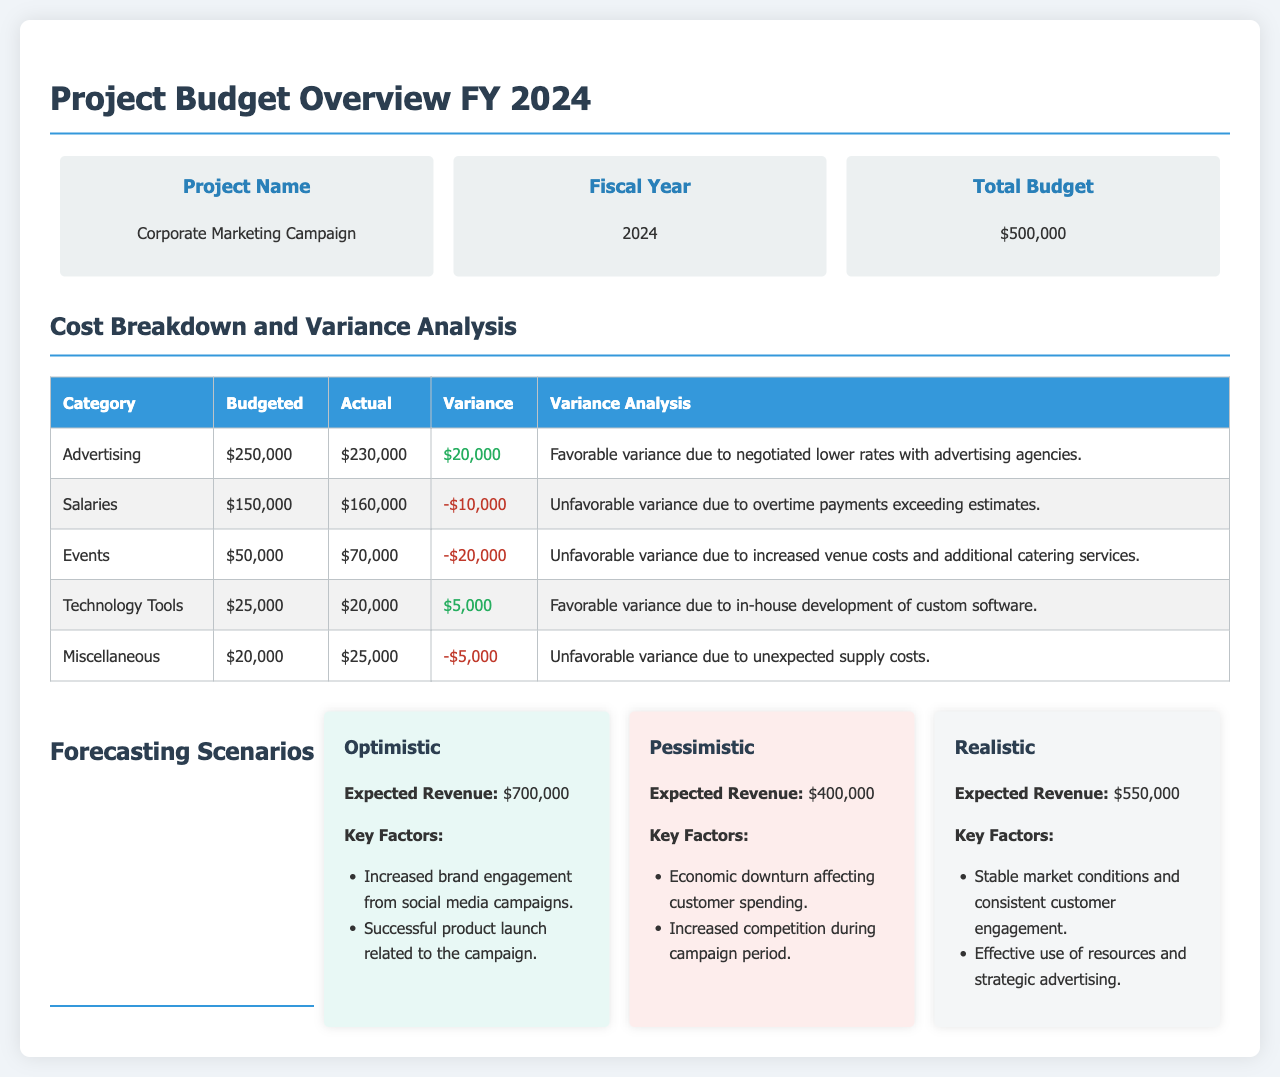What is the project name? The project name is listed in the budget overview section of the document.
Answer: Corporate Marketing Campaign What is the total budget? The total budget is stated in the budget overview section.
Answer: $500,000 What was the actual spending on Advertising? The actual spending on Advertising is provided in the cost breakdown table.
Answer: $230,000 What is the variance for Salaries? The variance for Salaries is calculated from the budgeted and actual amounts for that category.
Answer: -$10,000 What is the expected revenue in the pessimistic scenario? The expected revenue for the pessimistic scenario is explicitly mentioned in that section.
Answer: $400,000 What are the key factors for the realistic forecasting scenario? The key factors for the realistic forecasting scenario can be found listed under that scenario.
Answer: Stable market conditions and consistent customer engagement How much was budgeted for Events? The budgeted amount for Events is shown in the cost breakdown table.
Answer: $50,000 What caused the unfavorable variance in Events? The cause of the unfavorable variance is explained in the variance analysis column.
Answer: Increased venue costs and additional catering services What was the favorable variance for Technology Tools? The favorable variance for Technology Tools is provided in the cost breakdown table.
Answer: $5,000 